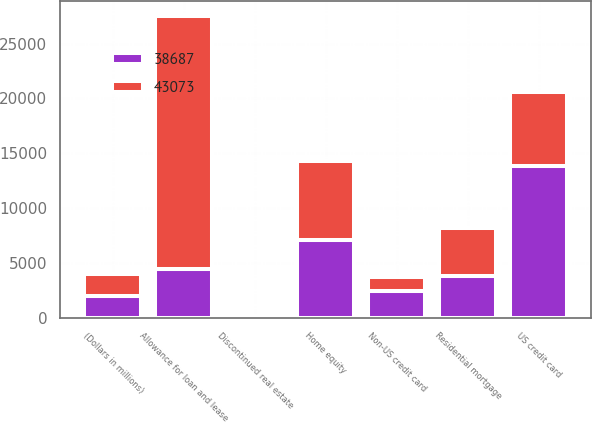Convert chart to OTSL. <chart><loc_0><loc_0><loc_500><loc_500><stacked_bar_chart><ecel><fcel>(Dollars in millions)<fcel>Allowance for loan and lease<fcel>Residential mortgage<fcel>Home equity<fcel>Discontinued real estate<fcel>US credit card<fcel>Non-US credit card<nl><fcel>38687<fcel>2010<fcel>4436<fcel>3779<fcel>7059<fcel>77<fcel>13818<fcel>2424<nl><fcel>43073<fcel>2009<fcel>23071<fcel>4436<fcel>7205<fcel>104<fcel>6753<fcel>1332<nl></chart> 